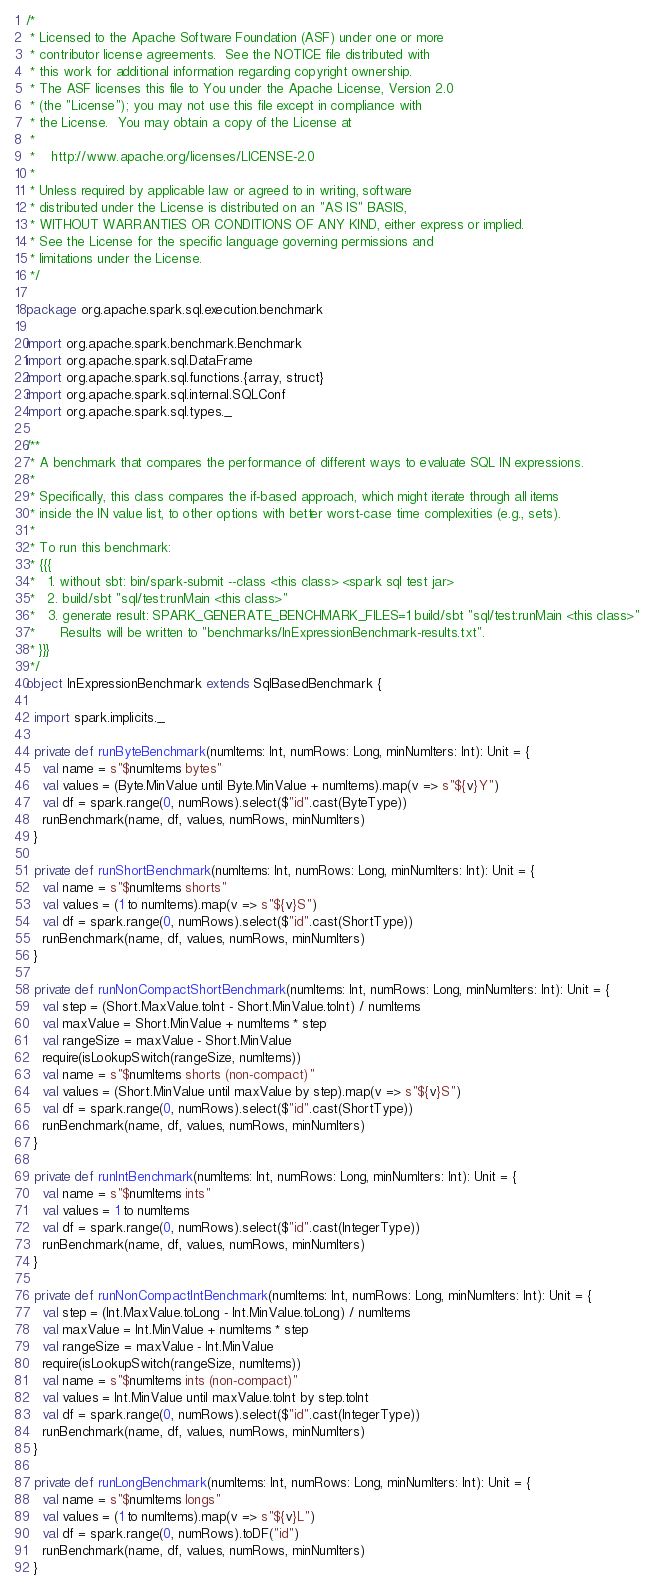Convert code to text. <code><loc_0><loc_0><loc_500><loc_500><_Scala_>/*
 * Licensed to the Apache Software Foundation (ASF) under one or more
 * contributor license agreements.  See the NOTICE file distributed with
 * this work for additional information regarding copyright ownership.
 * The ASF licenses this file to You under the Apache License, Version 2.0
 * (the "License"); you may not use this file except in compliance with
 * the License.  You may obtain a copy of the License at
 *
 *    http://www.apache.org/licenses/LICENSE-2.0
 *
 * Unless required by applicable law or agreed to in writing, software
 * distributed under the License is distributed on an "AS IS" BASIS,
 * WITHOUT WARRANTIES OR CONDITIONS OF ANY KIND, either express or implied.
 * See the License for the specific language governing permissions and
 * limitations under the License.
 */

package org.apache.spark.sql.execution.benchmark

import org.apache.spark.benchmark.Benchmark
import org.apache.spark.sql.DataFrame
import org.apache.spark.sql.functions.{array, struct}
import org.apache.spark.sql.internal.SQLConf
import org.apache.spark.sql.types._

/**
 * A benchmark that compares the performance of different ways to evaluate SQL IN expressions.
 *
 * Specifically, this class compares the if-based approach, which might iterate through all items
 * inside the IN value list, to other options with better worst-case time complexities (e.g., sets).
 *
 * To run this benchmark:
 * {{{
 *   1. without sbt: bin/spark-submit --class <this class> <spark sql test jar>
 *   2. build/sbt "sql/test:runMain <this class>"
 *   3. generate result: SPARK_GENERATE_BENCHMARK_FILES=1 build/sbt "sql/test:runMain <this class>"
 *      Results will be written to "benchmarks/InExpressionBenchmark-results.txt".
 * }}}
 */
object InExpressionBenchmark extends SqlBasedBenchmark {

  import spark.implicits._

  private def runByteBenchmark(numItems: Int, numRows: Long, minNumIters: Int): Unit = {
    val name = s"$numItems bytes"
    val values = (Byte.MinValue until Byte.MinValue + numItems).map(v => s"${v}Y")
    val df = spark.range(0, numRows).select($"id".cast(ByteType))
    runBenchmark(name, df, values, numRows, minNumIters)
  }

  private def runShortBenchmark(numItems: Int, numRows: Long, minNumIters: Int): Unit = {
    val name = s"$numItems shorts"
    val values = (1 to numItems).map(v => s"${v}S")
    val df = spark.range(0, numRows).select($"id".cast(ShortType))
    runBenchmark(name, df, values, numRows, minNumIters)
  }

  private def runNonCompactShortBenchmark(numItems: Int, numRows: Long, minNumIters: Int): Unit = {
    val step = (Short.MaxValue.toInt - Short.MinValue.toInt) / numItems
    val maxValue = Short.MinValue + numItems * step
    val rangeSize = maxValue - Short.MinValue
    require(isLookupSwitch(rangeSize, numItems))
    val name = s"$numItems shorts (non-compact)"
    val values = (Short.MinValue until maxValue by step).map(v => s"${v}S")
    val df = spark.range(0, numRows).select($"id".cast(ShortType))
    runBenchmark(name, df, values, numRows, minNumIters)
  }

  private def runIntBenchmark(numItems: Int, numRows: Long, minNumIters: Int): Unit = {
    val name = s"$numItems ints"
    val values = 1 to numItems
    val df = spark.range(0, numRows).select($"id".cast(IntegerType))
    runBenchmark(name, df, values, numRows, minNumIters)
  }

  private def runNonCompactIntBenchmark(numItems: Int, numRows: Long, minNumIters: Int): Unit = {
    val step = (Int.MaxValue.toLong - Int.MinValue.toLong) / numItems
    val maxValue = Int.MinValue + numItems * step
    val rangeSize = maxValue - Int.MinValue
    require(isLookupSwitch(rangeSize, numItems))
    val name = s"$numItems ints (non-compact)"
    val values = Int.MinValue until maxValue.toInt by step.toInt
    val df = spark.range(0, numRows).select($"id".cast(IntegerType))
    runBenchmark(name, df, values, numRows, minNumIters)
  }

  private def runLongBenchmark(numItems: Int, numRows: Long, minNumIters: Int): Unit = {
    val name = s"$numItems longs"
    val values = (1 to numItems).map(v => s"${v}L")
    val df = spark.range(0, numRows).toDF("id")
    runBenchmark(name, df, values, numRows, minNumIters)
  }
</code> 